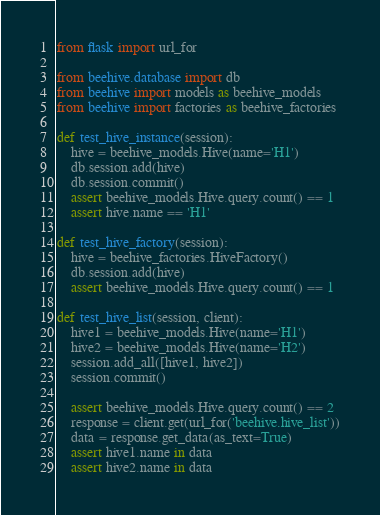Convert code to text. <code><loc_0><loc_0><loc_500><loc_500><_Python_>from flask import url_for

from beehive.database import db
from beehive import models as beehive_models
from beehive import factories as beehive_factories

def test_hive_instance(session):
    hive = beehive_models.Hive(name='H1')
    db.session.add(hive)
    db.session.commit()
    assert beehive_models.Hive.query.count() == 1
    assert hive.name == 'H1'

def test_hive_factory(session):
    hive = beehive_factories.HiveFactory()
    db.session.add(hive)
    assert beehive_models.Hive.query.count() == 1

def test_hive_list(session, client):
    hive1 = beehive_models.Hive(name='H1')
    hive2 = beehive_models.Hive(name='H2')
    session.add_all([hive1, hive2])
    session.commit()

    assert beehive_models.Hive.query.count() == 2
    response = client.get(url_for('beehive.hive_list'))
    data = response.get_data(as_text=True)
    assert hive1.name in data
    assert hive2.name in data
</code> 